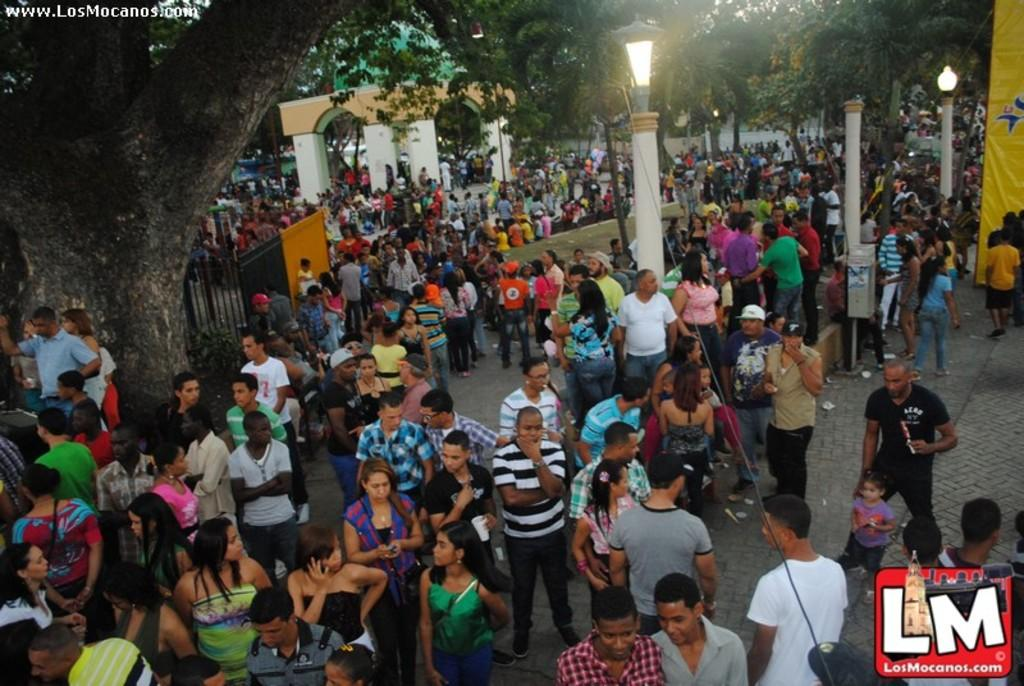What is the main subject of the image? The main subject of the image is a crowd. How is the crowd positioned in the image? The crowd is standing in the image. What type of natural elements can be seen in the image? There are trees visible in the image. What type of structures can be seen in the image? There are poles and a gate in the image. What type of illumination is present in the image? There are lights in the image. What type of signage is present in the image? There is a board in the image. What type of celery is being used as a decoration in the image? There is no celery present in the image. What type of bird can be seen perched on the gate in the image? There is no bird present in the image, let alone a specific type like a wren. 